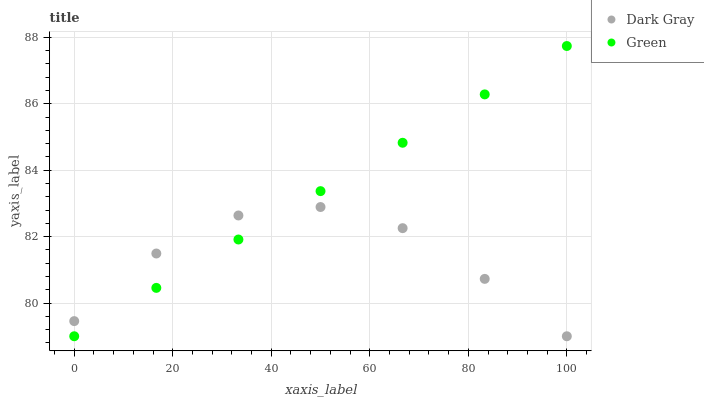Does Dark Gray have the minimum area under the curve?
Answer yes or no. Yes. Does Green have the maximum area under the curve?
Answer yes or no. Yes. Does Green have the minimum area under the curve?
Answer yes or no. No. Is Green the smoothest?
Answer yes or no. Yes. Is Dark Gray the roughest?
Answer yes or no. Yes. Is Green the roughest?
Answer yes or no. No. Does Dark Gray have the lowest value?
Answer yes or no. Yes. Does Green have the highest value?
Answer yes or no. Yes. Does Dark Gray intersect Green?
Answer yes or no. Yes. Is Dark Gray less than Green?
Answer yes or no. No. Is Dark Gray greater than Green?
Answer yes or no. No. 